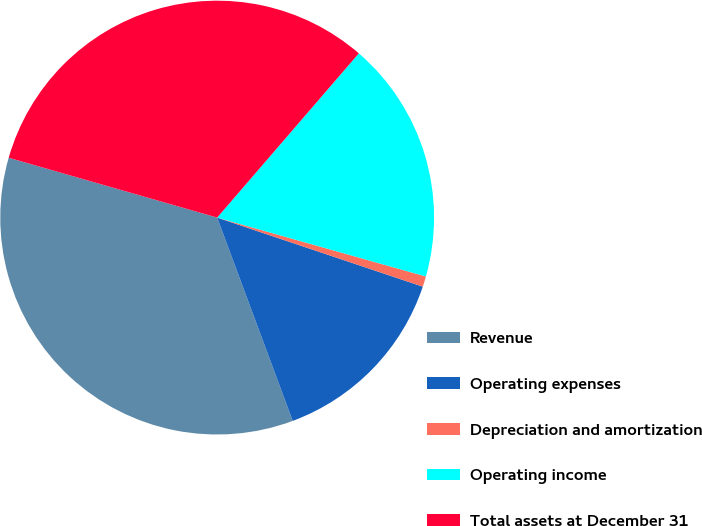<chart> <loc_0><loc_0><loc_500><loc_500><pie_chart><fcel>Revenue<fcel>Operating expenses<fcel>Depreciation and amortization<fcel>Operating income<fcel>Total assets at December 31<nl><fcel>35.11%<fcel>14.18%<fcel>0.78%<fcel>18.05%<fcel>31.88%<nl></chart> 